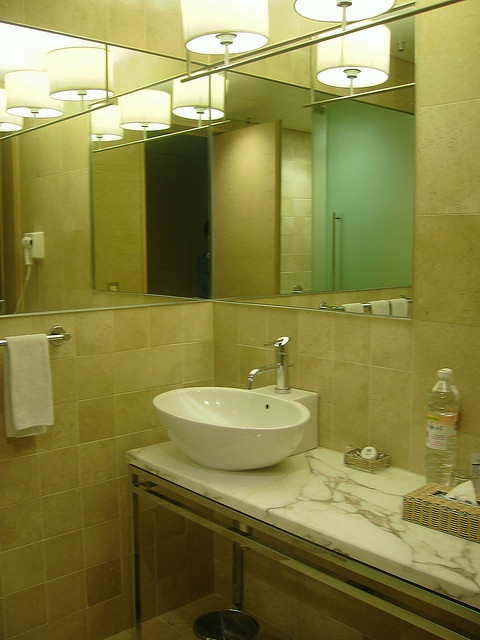Describe the objects in this image and their specific colors. I can see sink in olive, khaki, and tan tones, bottle in olive tones, and hair drier in olive tones in this image. 